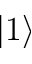Convert formula to latex. <formula><loc_0><loc_0><loc_500><loc_500>| 1 \rangle</formula> 